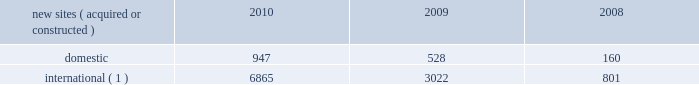2022 international .
In general , our international markets are less advanced with respect to the current technologies deployed for wireless services .
As a result , demand for our communications sites is driven by continued voice network investments , new market entrants and initial 3g data network deployments .
For example , in india , nationwide voice networks continue to be deployed as wireless service providers are beginning their initial investments in 3g data networks , as a result of recent spectrum auctions .
In mexico and brazil , where nationwide voice networks have been deployed , some incumbent wireless service providers continue to invest in their 3g data networks , and recent spectrum auctions have enabled other incumbent wireless service providers and new market entrants to begin their initial investments in 3g data networks .
In markets such as chile and peru , recent spectrum auctions have attracted new market entrants , who are expected to begin their investment in deploying nationwide voice and 3g data networks .
We believe demand for our tower sites will continue in our international markets as wireless service providers seek to remain competitive by increasing the coverage of their networks while also investing in next generation data networks .
Rental and management operations new site revenue growth .
During the year ended december 31 , 2010 , we grew our portfolio of communications sites through acquisitions and construction activities , including the acquisition and construction of approximately 7800 sites .
We continue to evaluate opportunities to acquire larger communications site portfolios , both domestically and internationally , that we believe we can effectively integrate into our existing portfolio. .
( 1 ) the majority of sites acquired or constructed internationally during 2010 and 2009 were in india and our newly launched operations in chile , colombia and peru .
Network development services segment revenue growth .
As we continue to focus on growing our rental and management operations , we anticipate that our network development services revenue will continue to represent a small percentage of our total revenues .
Through our network development services segment , we offer tower-related services , including site acquisition , zoning and permitting services and structural analysis services , which primarily support our site leasing business and the addition of new tenants and equipment on our sites .
Rental and management operations expenses .
Our rental and management operations expenses include our direct site level expenses and consist primarily of ground rent , property taxes , repairs and maintenance and utilities .
These segment level expenses exclude all segment and corporate level selling , general , administrative and development expenses , which are aggregated into one line item entitled selling , general , administrative and development expense .
In general , our rental and management segment level selling , general and administrative expenses do not significantly increase as a result of adding incremental tenants to our legacy sites and typically increase only modestly year-over-year .
As a result , leasing additional space to new tenants on our legacy sites provides significant incremental cash flow .
In geographic areas where we have recently launched operations or are focused on materially expanding our site footprint , we may incur additional segment level selling , general and administrative expenses as we increase our presence in these areas .
Our profit margin growth is therefore positively impacted by the addition of new tenants to our legacy sites and can be temporarily diluted by our development activities .
Reit election .
As we review our tax strategy and assess the utilization of our federal and state nols , we are actively considering an election to a reit for u.s .
Federal and , where applicable , state income tax purposes .
We may make the determination to elect reit status for the taxable year beginning january 1 , 2012 , as early as the second half of 2011 , subject to the approval of our board of directors , although there is no certainty as to the timing of a reit election or whether we will make a reit election at all. .
What portion of the new sites acquired or constructed during 2010 is located in united states? 
Computations: (947 / (947 + 6865))
Answer: 0.12122. 